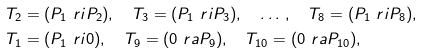<formula> <loc_0><loc_0><loc_500><loc_500>& T _ { 2 } = ( P _ { 1 } \ r i P _ { 2 } ) , \quad T _ { 3 } = ( P _ { 1 } \ r i P _ { 3 } ) , \quad \dots \, , \quad T _ { 8 } = ( P _ { 1 } \ r i P _ { 8 } ) , \quad \\ & T _ { 1 } = ( P _ { 1 } \ r i 0 ) , \quad T _ { 9 } = ( 0 \ r a P _ { 9 } ) , \quad T _ { 1 0 } = ( 0 \ r a P _ { 1 0 } ) ,</formula> 